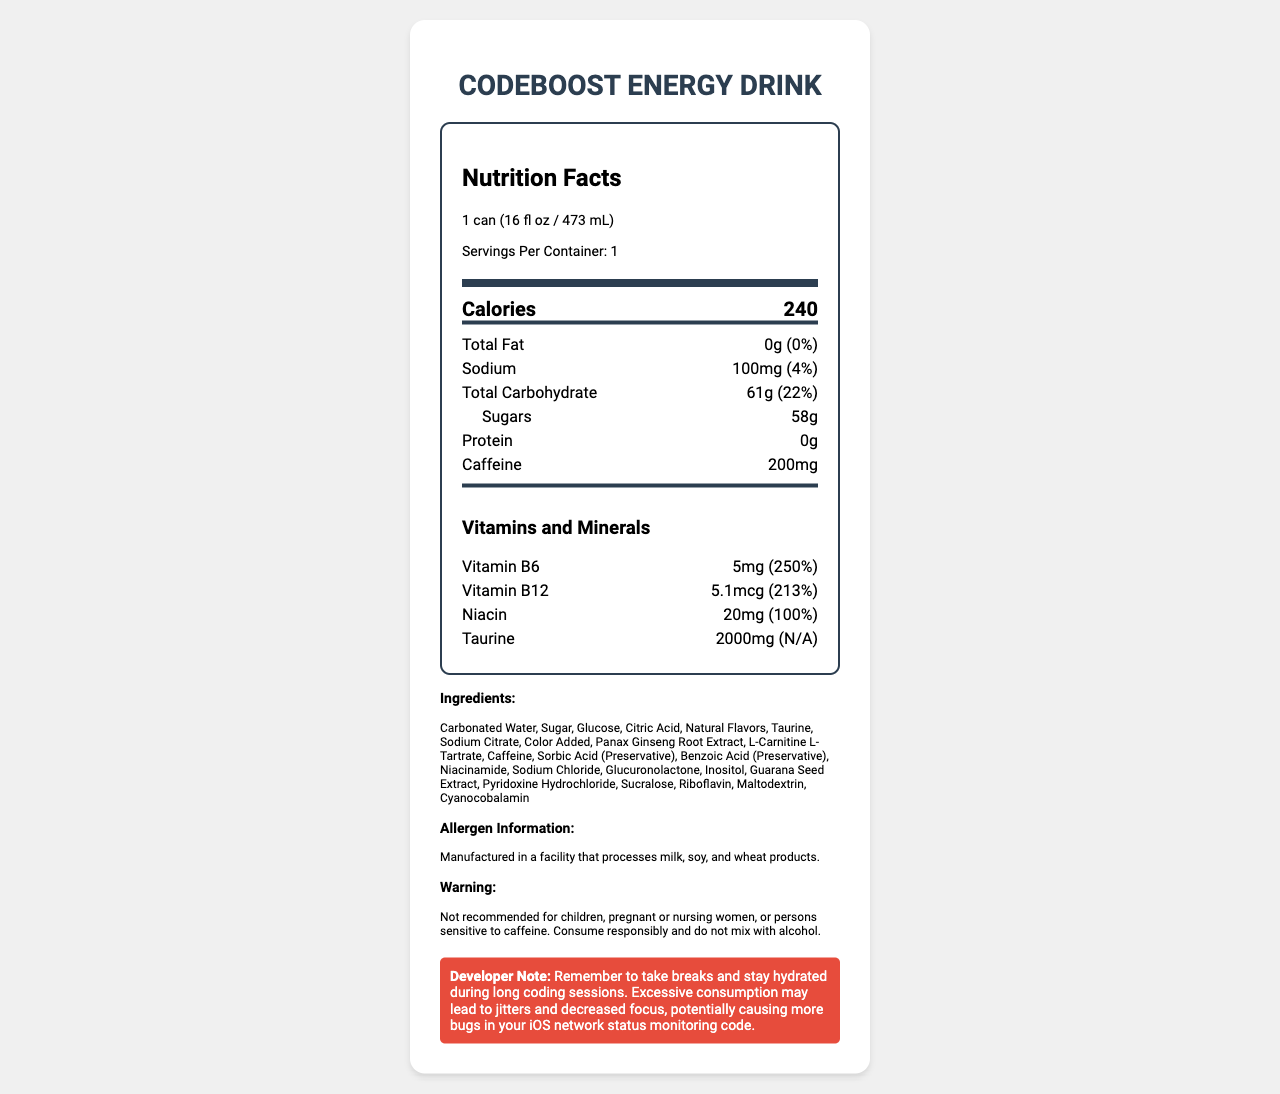who should not consume this product? The warning section of the document specifies that it is not recommended for children, pregnant or nursing women, or persons sensitive to caffeine.
Answer: Children, pregnant or nursing women, or persons sensitive to caffeine what is the serving size of the CodeBoost Energy Drink? The label mentions that the serving size is "1 can (16 fl oz / 473 mL)".
Answer: 1 can (16 fl oz / 473 mL) how much caffeine is in one serving of this product? The nutrient section of the document lists the amount of caffeine as 200mg.
Answer: 200mg name two vitamins present in the CodeBoost Energy Drink and their amounts. The vitamins section shows that the drink contains Vitamin B6 (5mg) and Vitamin B12 (5.1mcg).
Answer: Vitamin B6: 5mg, Vitamin B12: 5.1mcg what is the daily value percentage of sodium per serving? The sodium section shows that the daily value percentage for sodium is 4%.
Answer: 4% which of the following ingredients is used as a preservative?
A. Sorbic Acid
B. Taurine
C. Niacinamide According to the ingredients list, Sorbic Acid is labeled as a preservative.
Answer: A. Sorbic Acid what type of facility is this product manufactured in?
A. Facility that processes milk only
B. Facility that processes soy only
C. Facility that processes milk, soy, and wheat products
D. Facility that processes wheat products only The allergen information section states that the product is manufactured in a facility that processes milk, soy, and wheat products.
Answer: C is the developer note an essential part of nutrition labeling? The developer note section is not part of the typical nutrition labeling; it's included to remind developers to take breaks and hydrate.
Answer: No summarize the main idea of the Nutrition Facts Label document for CodeBoost Energy Drink. The document comprehensively outlines the nutritional aspects, ingredients, and warnings associated with CodeBoost Energy Drink, as well as a note for developers to ensure they consume the drink responsibly during coding sessions.
Answer: The document provides the nutritional information of CodeBoost Energy Drink, including serving size, calorie count, macronutrients, vitamins, and minerals. It lists the ingredients, allergen information, and a cautionary warning regarding consumption. Additionally, there is a developer note encouraging responsible consumption and hydration. what is the source of glucose in the CodeBoost Energy Drink? The document lists glucose as an ingredient, but it does not specify the source of glucose used.
Answer: Not enough information 